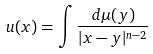<formula> <loc_0><loc_0><loc_500><loc_500>u ( x ) = \int \frac { d \mu ( y ) } { | x - y | ^ { n - 2 } }</formula> 